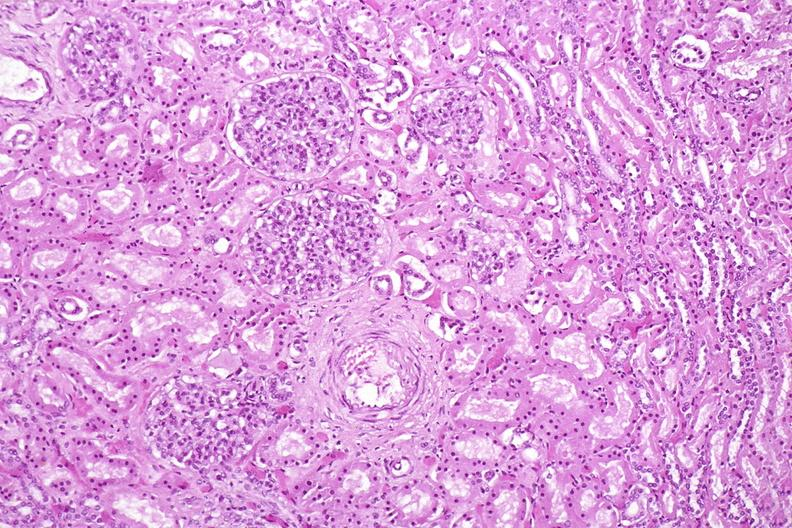does this image show kidney, normal histology?
Answer the question using a single word or phrase. Yes 